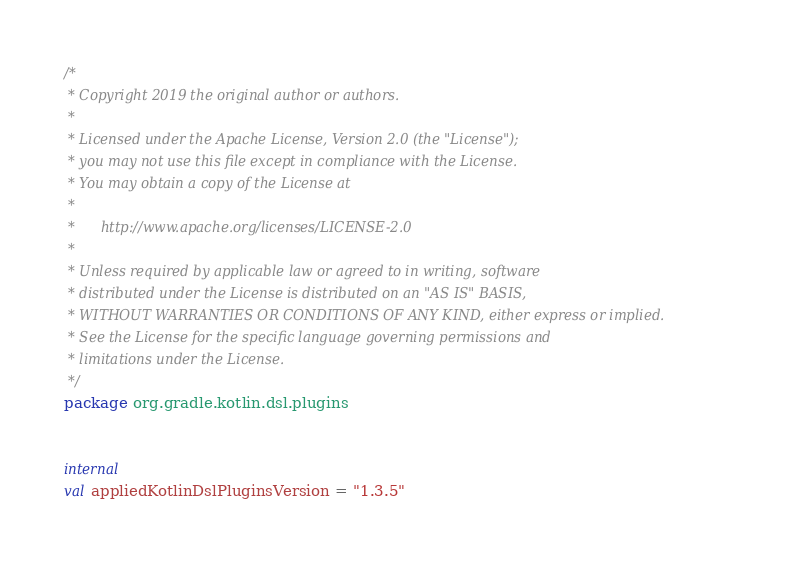<code> <loc_0><loc_0><loc_500><loc_500><_Kotlin_>/*
 * Copyright 2019 the original author or authors.
 *
 * Licensed under the Apache License, Version 2.0 (the "License");
 * you may not use this file except in compliance with the License.
 * You may obtain a copy of the License at
 *
 *      http://www.apache.org/licenses/LICENSE-2.0
 *
 * Unless required by applicable law or agreed to in writing, software
 * distributed under the License is distributed on an "AS IS" BASIS,
 * WITHOUT WARRANTIES OR CONDITIONS OF ANY KIND, either express or implied.
 * See the License for the specific language governing permissions and
 * limitations under the License.
 */
package org.gradle.kotlin.dsl.plugins


internal
val appliedKotlinDslPluginsVersion = "1.3.5"
</code> 